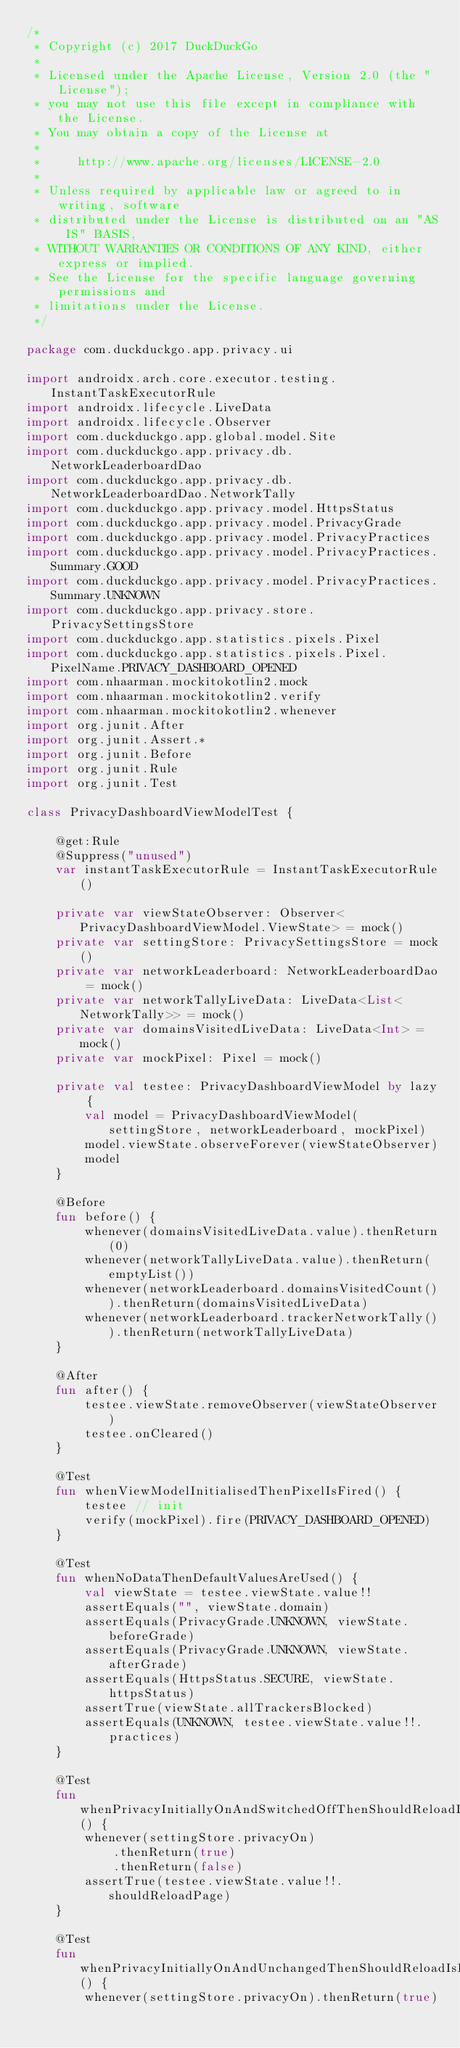<code> <loc_0><loc_0><loc_500><loc_500><_Kotlin_>/*
 * Copyright (c) 2017 DuckDuckGo
 *
 * Licensed under the Apache License, Version 2.0 (the "License");
 * you may not use this file except in compliance with the License.
 * You may obtain a copy of the License at
 *
 *     http://www.apache.org/licenses/LICENSE-2.0
 *
 * Unless required by applicable law or agreed to in writing, software
 * distributed under the License is distributed on an "AS IS" BASIS,
 * WITHOUT WARRANTIES OR CONDITIONS OF ANY KIND, either express or implied.
 * See the License for the specific language governing permissions and
 * limitations under the License.
 */

package com.duckduckgo.app.privacy.ui

import androidx.arch.core.executor.testing.InstantTaskExecutorRule
import androidx.lifecycle.LiveData
import androidx.lifecycle.Observer
import com.duckduckgo.app.global.model.Site
import com.duckduckgo.app.privacy.db.NetworkLeaderboardDao
import com.duckduckgo.app.privacy.db.NetworkLeaderboardDao.NetworkTally
import com.duckduckgo.app.privacy.model.HttpsStatus
import com.duckduckgo.app.privacy.model.PrivacyGrade
import com.duckduckgo.app.privacy.model.PrivacyPractices
import com.duckduckgo.app.privacy.model.PrivacyPractices.Summary.GOOD
import com.duckduckgo.app.privacy.model.PrivacyPractices.Summary.UNKNOWN
import com.duckduckgo.app.privacy.store.PrivacySettingsStore
import com.duckduckgo.app.statistics.pixels.Pixel
import com.duckduckgo.app.statistics.pixels.Pixel.PixelName.PRIVACY_DASHBOARD_OPENED
import com.nhaarman.mockitokotlin2.mock
import com.nhaarman.mockitokotlin2.verify
import com.nhaarman.mockitokotlin2.whenever
import org.junit.After
import org.junit.Assert.*
import org.junit.Before
import org.junit.Rule
import org.junit.Test

class PrivacyDashboardViewModelTest {

    @get:Rule
    @Suppress("unused")
    var instantTaskExecutorRule = InstantTaskExecutorRule()

    private var viewStateObserver: Observer<PrivacyDashboardViewModel.ViewState> = mock()
    private var settingStore: PrivacySettingsStore = mock()
    private var networkLeaderboard: NetworkLeaderboardDao = mock()
    private var networkTallyLiveData: LiveData<List<NetworkTally>> = mock()
    private var domainsVisitedLiveData: LiveData<Int> = mock()
    private var mockPixel: Pixel = mock()

    private val testee: PrivacyDashboardViewModel by lazy {
        val model = PrivacyDashboardViewModel(settingStore, networkLeaderboard, mockPixel)
        model.viewState.observeForever(viewStateObserver)
        model
    }

    @Before
    fun before() {
        whenever(domainsVisitedLiveData.value).thenReturn(0)
        whenever(networkTallyLiveData.value).thenReturn(emptyList())
        whenever(networkLeaderboard.domainsVisitedCount()).thenReturn(domainsVisitedLiveData)
        whenever(networkLeaderboard.trackerNetworkTally()).thenReturn(networkTallyLiveData)
    }

    @After
    fun after() {
        testee.viewState.removeObserver(viewStateObserver)
        testee.onCleared()
    }

    @Test
    fun whenViewModelInitialisedThenPixelIsFired() {
        testee // init
        verify(mockPixel).fire(PRIVACY_DASHBOARD_OPENED)
    }

    @Test
    fun whenNoDataThenDefaultValuesAreUsed() {
        val viewState = testee.viewState.value!!
        assertEquals("", viewState.domain)
        assertEquals(PrivacyGrade.UNKNOWN, viewState.beforeGrade)
        assertEquals(PrivacyGrade.UNKNOWN, viewState.afterGrade)
        assertEquals(HttpsStatus.SECURE, viewState.httpsStatus)
        assertTrue(viewState.allTrackersBlocked)
        assertEquals(UNKNOWN, testee.viewState.value!!.practices)
    }

    @Test
    fun whenPrivacyInitiallyOnAndSwitchedOffThenShouldReloadIsTrue() {
        whenever(settingStore.privacyOn)
            .thenReturn(true)
            .thenReturn(false)
        assertTrue(testee.viewState.value!!.shouldReloadPage)
    }

    @Test
    fun whenPrivacyInitiallyOnAndUnchangedThenShouldReloadIsFalse() {
        whenever(settingStore.privacyOn).thenReturn(true)</code> 